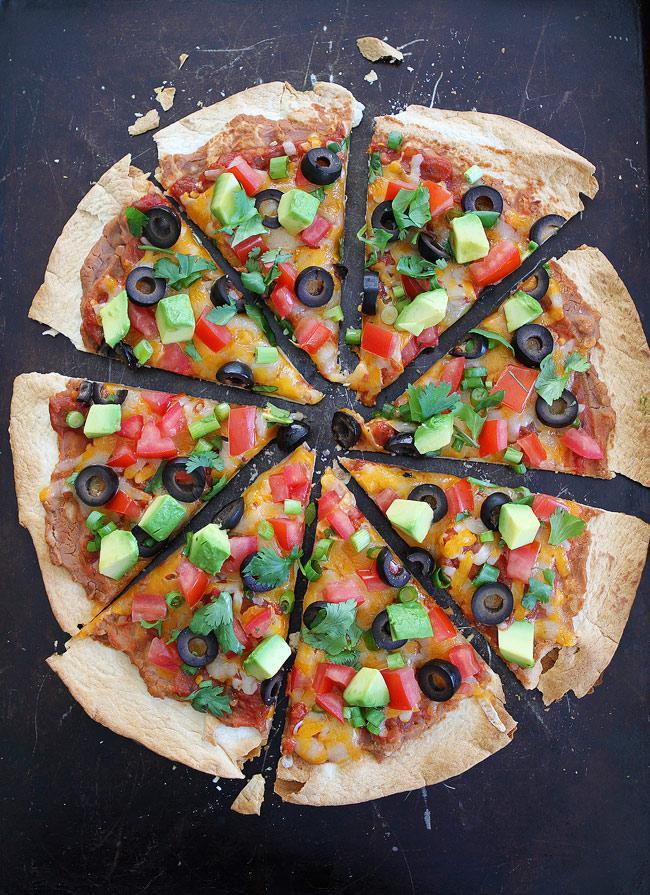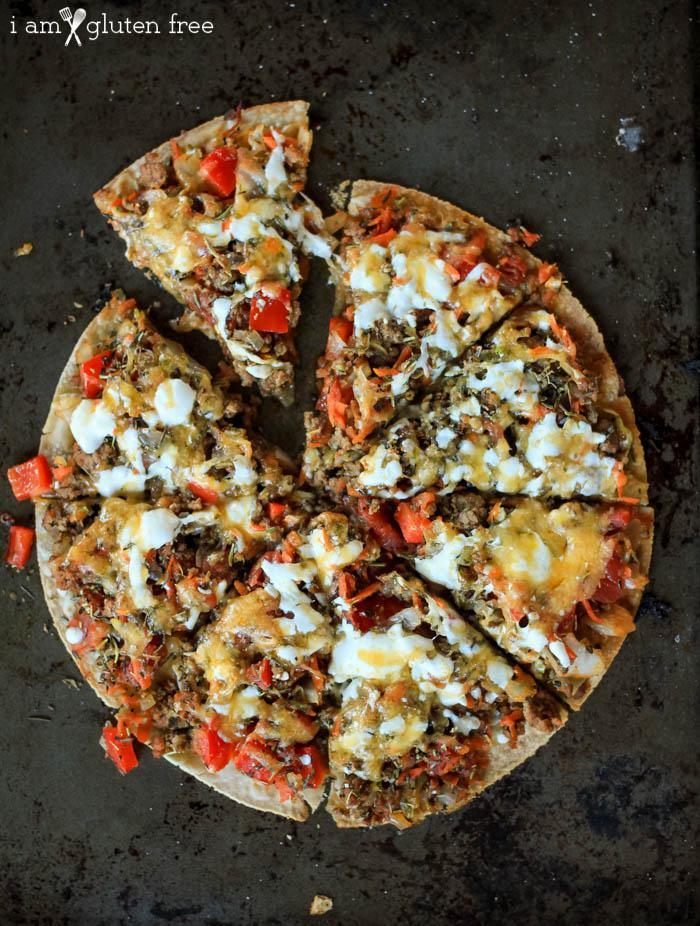The first image is the image on the left, the second image is the image on the right. Analyze the images presented: Is the assertion "A single slice is pulled away from the otherwise whole pizza in the image on the left." valid? Answer yes or no. No. 